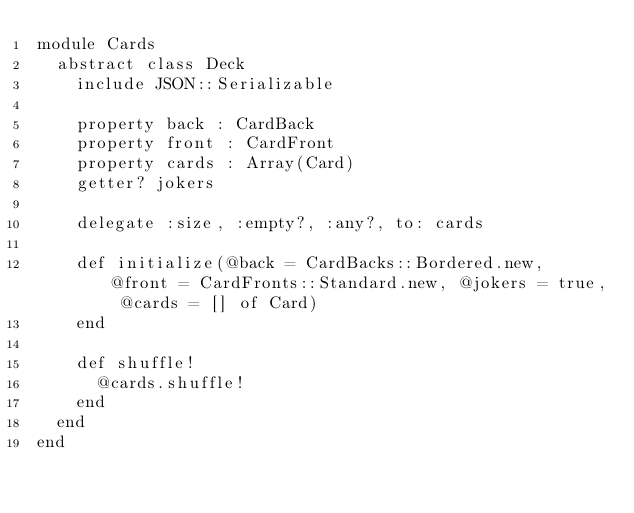Convert code to text. <code><loc_0><loc_0><loc_500><loc_500><_Crystal_>module Cards
  abstract class Deck
    include JSON::Serializable

    property back : CardBack
    property front : CardFront
    property cards : Array(Card)
    getter? jokers

    delegate :size, :empty?, :any?, to: cards

    def initialize(@back = CardBacks::Bordered.new, @front = CardFronts::Standard.new, @jokers = true, @cards = [] of Card)
    end

    def shuffle!
      @cards.shuffle!
    end
  end
end
</code> 